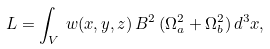Convert formula to latex. <formula><loc_0><loc_0><loc_500><loc_500>L = \int _ { V } \, w ( x , y , z ) \, B ^ { 2 } \, ( \Omega _ { a } ^ { 2 } + \Omega _ { b } ^ { 2 } ) \, d ^ { 3 } x ,</formula> 